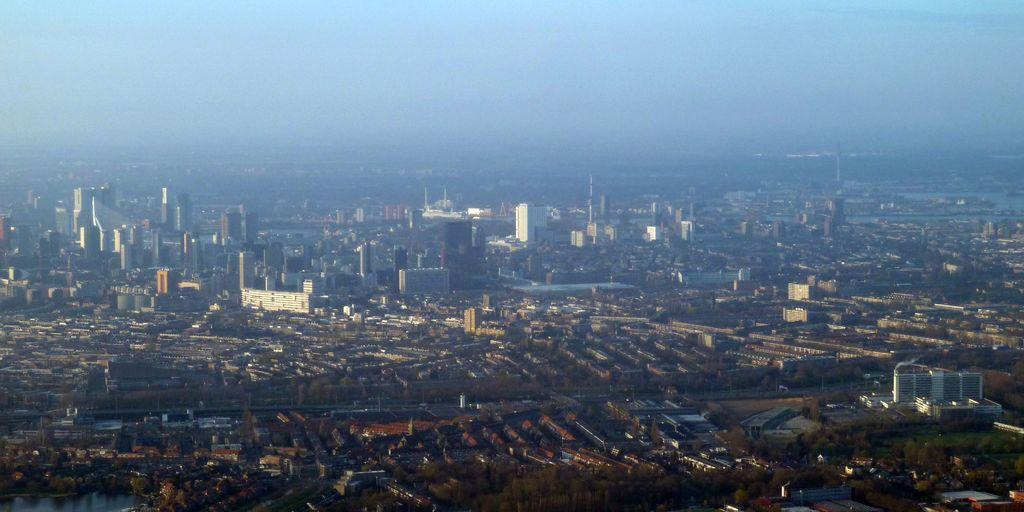What color is the sky in the image? The sky is blue in the image. What type of structures can be seen in the image? There are buildings in the image. What type of vegetation is present in the image? There are trees in the image. What time of day is it in the image, based on the position of the mouth? There is no mouth present in the image, so it is not possible to determine the time of day based on that information. 